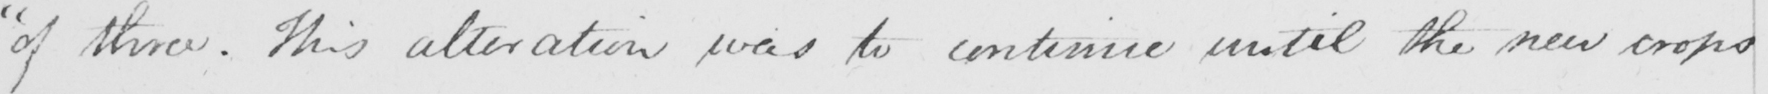What is written in this line of handwriting? " of three . This alteration was to continue until the new crops 